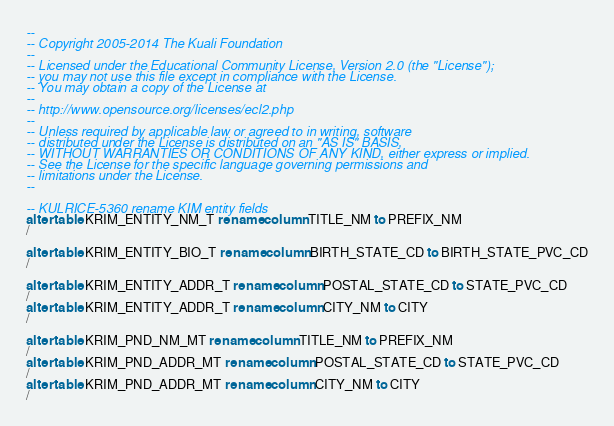Convert code to text. <code><loc_0><loc_0><loc_500><loc_500><_SQL_>--
-- Copyright 2005-2014 The Kuali Foundation
--
-- Licensed under the Educational Community License, Version 2.0 (the "License");
-- you may not use this file except in compliance with the License.
-- You may obtain a copy of the License at
--
-- http://www.opensource.org/licenses/ecl2.php
--
-- Unless required by applicable law or agreed to in writing, software
-- distributed under the License is distributed on an "AS IS" BASIS,
-- WITHOUT WARRANTIES OR CONDITIONS OF ANY KIND, either express or implied.
-- See the License for the specific language governing permissions and
-- limitations under the License.
--

-- KULRICE-5360 rename KIM entity fields
alter table KRIM_ENTITY_NM_T rename column TITLE_NM to PREFIX_NM
/

alter table KRIM_ENTITY_BIO_T rename column BIRTH_STATE_CD to BIRTH_STATE_PVC_CD
/

alter table KRIM_ENTITY_ADDR_T rename column POSTAL_STATE_CD to STATE_PVC_CD
/
alter table KRIM_ENTITY_ADDR_T rename column CITY_NM to CITY
/

alter table KRIM_PND_NM_MT rename column TITLE_NM to PREFIX_NM
/
alter table KRIM_PND_ADDR_MT rename column POSTAL_STATE_CD to STATE_PVC_CD
/
alter table KRIM_PND_ADDR_MT rename column CITY_NM to CITY
/
</code> 